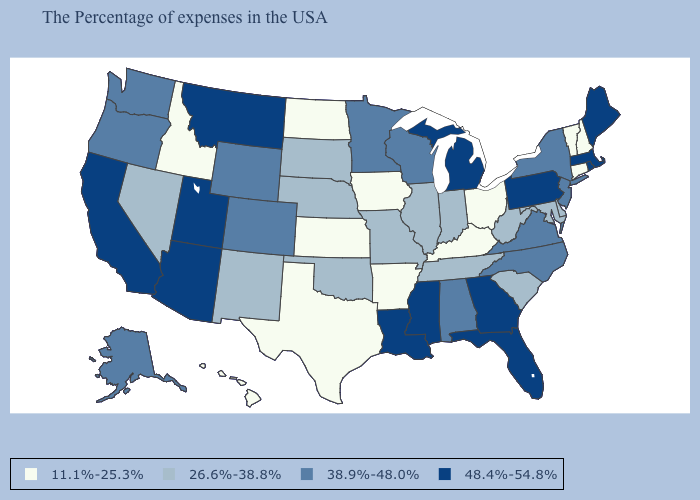Name the states that have a value in the range 48.4%-54.8%?
Write a very short answer. Maine, Massachusetts, Rhode Island, Pennsylvania, Florida, Georgia, Michigan, Mississippi, Louisiana, Utah, Montana, Arizona, California. Does South Dakota have a lower value than New Hampshire?
Concise answer only. No. What is the value of West Virginia?
Answer briefly. 26.6%-38.8%. Does Tennessee have a lower value than Florida?
Short answer required. Yes. What is the lowest value in the USA?
Write a very short answer. 11.1%-25.3%. Name the states that have a value in the range 11.1%-25.3%?
Answer briefly. New Hampshire, Vermont, Connecticut, Ohio, Kentucky, Arkansas, Iowa, Kansas, Texas, North Dakota, Idaho, Hawaii. Name the states that have a value in the range 26.6%-38.8%?
Short answer required. Delaware, Maryland, South Carolina, West Virginia, Indiana, Tennessee, Illinois, Missouri, Nebraska, Oklahoma, South Dakota, New Mexico, Nevada. Which states have the lowest value in the MidWest?
Keep it brief. Ohio, Iowa, Kansas, North Dakota. Name the states that have a value in the range 11.1%-25.3%?
Quick response, please. New Hampshire, Vermont, Connecticut, Ohio, Kentucky, Arkansas, Iowa, Kansas, Texas, North Dakota, Idaho, Hawaii. Name the states that have a value in the range 26.6%-38.8%?
Answer briefly. Delaware, Maryland, South Carolina, West Virginia, Indiana, Tennessee, Illinois, Missouri, Nebraska, Oklahoma, South Dakota, New Mexico, Nevada. What is the value of California?
Keep it brief. 48.4%-54.8%. What is the highest value in the West ?
Answer briefly. 48.4%-54.8%. Among the states that border Maryland , does Virginia have the highest value?
Short answer required. No. What is the value of Maine?
Short answer required. 48.4%-54.8%. 